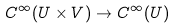<formula> <loc_0><loc_0><loc_500><loc_500>C ^ { \infty } ( U \times V ) \to C ^ { \infty } ( U )</formula> 